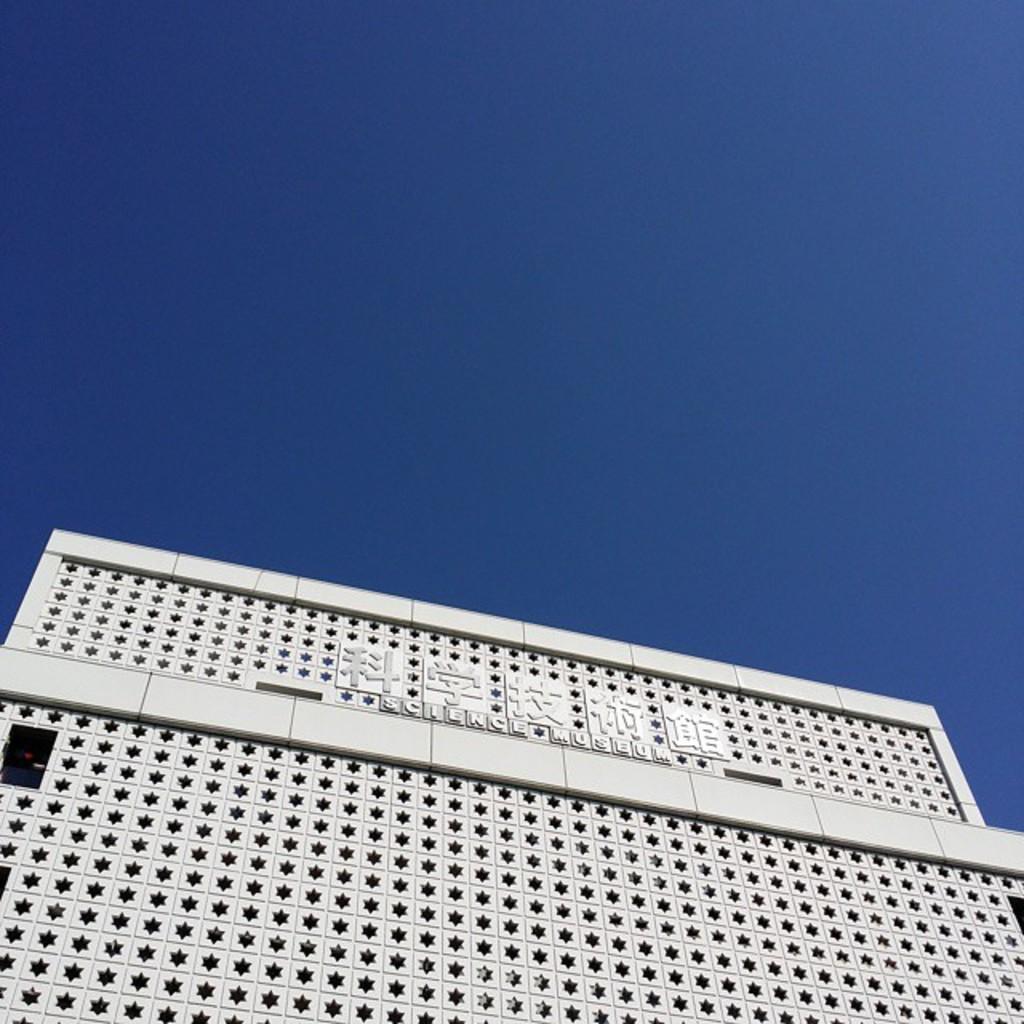Describe this image in one or two sentences. In this picture there is a building which has something written on it and the sky is in blue color. 